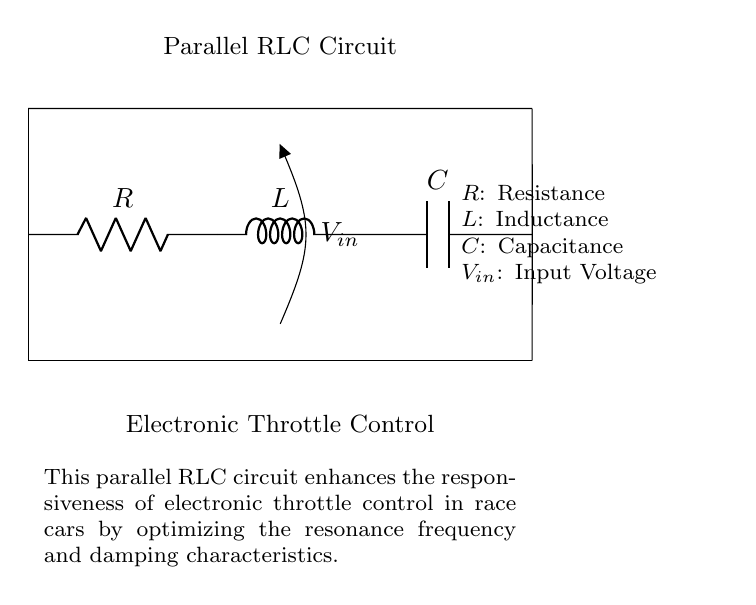What are the components in this circuit? The circuit diagram includes three components: a resistor, an inductor, and a capacitor, clearly labeled as R, L, and C.
Answer: Resistor, Inductor, Capacitor What is the purpose of the RLC circuit in this diagram? The circuit enhances the responsiveness of electronic throttle control in race cars by optimizing resonance frequency and damping characteristics, as mentioned in the diagram.
Answer: Enhance throttle responsiveness What type of circuit is shown in the diagram? The diagram depicts a parallel RLC circuit, as indicated by the arrangement of the resistor, inductor, and capacitor in parallel with each other.
Answer: Parallel RLC circuit What is the significance of the input voltage labeled V_in? V_in represents the input voltage to the parallel RLC circuit, which is essential for the functioning of the electronic throttle control and affects the circuit's behavior.
Answer: Input voltage for circuit operation What happens to the circuit's impedance at resonance? At resonance, the impedance of a parallel RLC circuit is minimized, which allows maximum current to flow through the circuit, optimizing performance in the electronic throttle application.
Answer: Impedance is minimized How do the components R, L, and C affect circuit damping? The resistance (R) influences the damping factor of the circuit, while the inductor (L) and capacitor (C) determine the resonant frequency; together, they define the transient response and system stability.
Answer: Resistance affects damping 